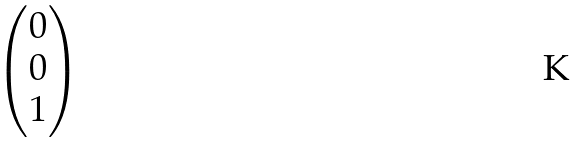<formula> <loc_0><loc_0><loc_500><loc_500>\begin{pmatrix} 0 \\ 0 \\ 1 \\ \end{pmatrix}</formula> 